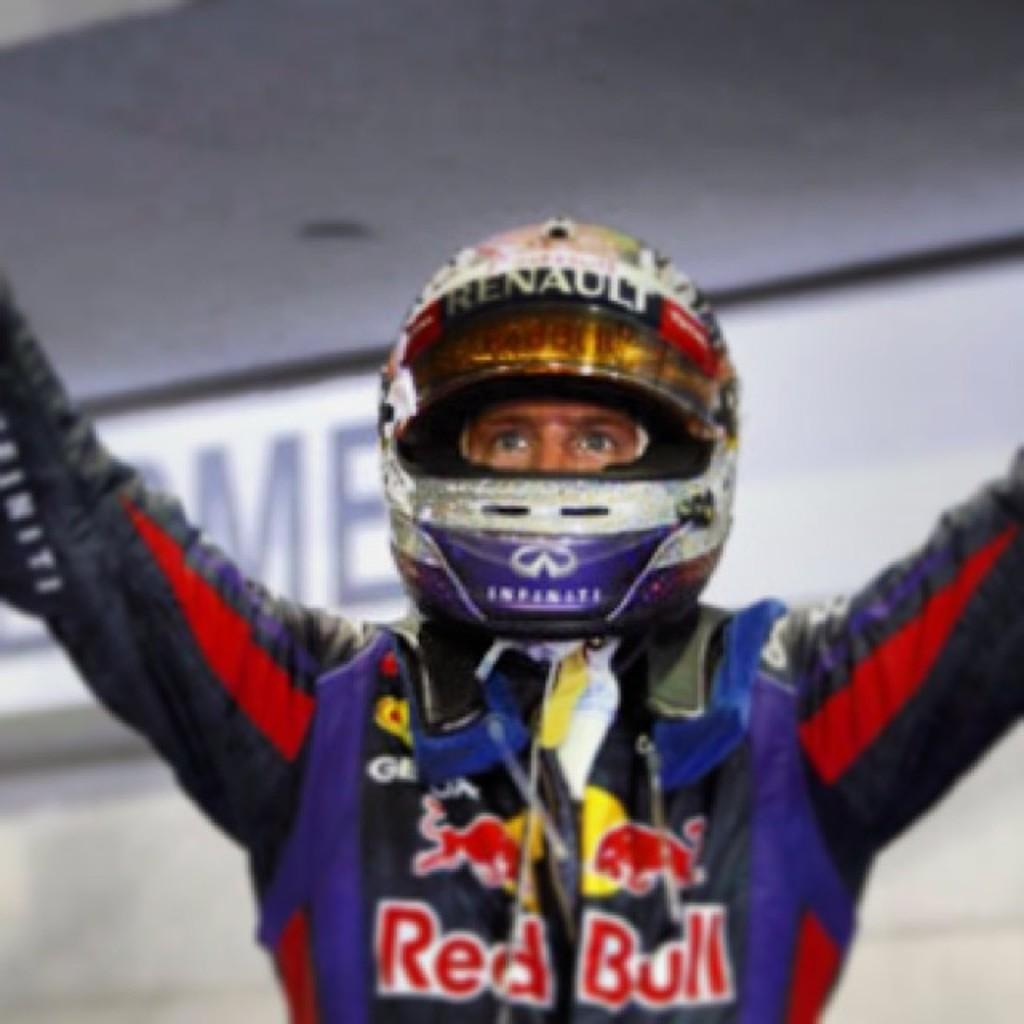What can be observed about the background of the image? The background portion of the picture is blurry. What object is present in the image? There is a board in the image. Who or what is in the image? There is a person in the image. What is the person wearing? The person is wearing a helmet. Can you see any playing cards in the image? There are no playing cards present in the image. Is there a fowl in the image? There is no fowl present in the image. 